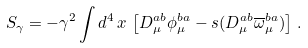<formula> <loc_0><loc_0><loc_500><loc_500>S _ { \gamma } = - \gamma ^ { 2 } \int d ^ { 4 } \, x \, \left [ D _ { \mu } ^ { a b } \phi _ { \mu } ^ { b a } - s ( D _ { \mu } ^ { a b } \overline { \omega } _ { \mu } ^ { b a } ) \right ] \, .</formula> 